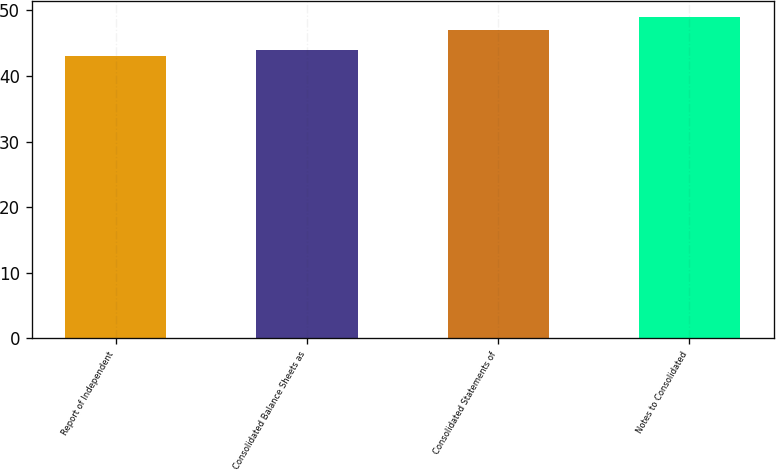Convert chart. <chart><loc_0><loc_0><loc_500><loc_500><bar_chart><fcel>Report of Independent<fcel>Consolidated Balance Sheets as<fcel>Consolidated Statements of<fcel>Notes to Consolidated<nl><fcel>43<fcel>44<fcel>47<fcel>49<nl></chart> 